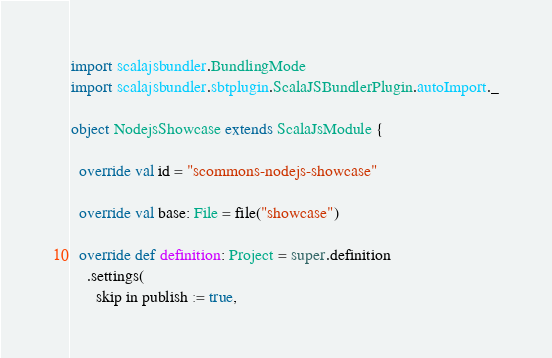<code> <loc_0><loc_0><loc_500><loc_500><_Scala_>import scalajsbundler.BundlingMode
import scalajsbundler.sbtplugin.ScalaJSBundlerPlugin.autoImport._

object NodejsShowcase extends ScalaJsModule {

  override val id = "scommons-nodejs-showcase"

  override val base: File = file("showcase")

  override def definition: Project = super.definition
    .settings(
      skip in publish := true,</code> 